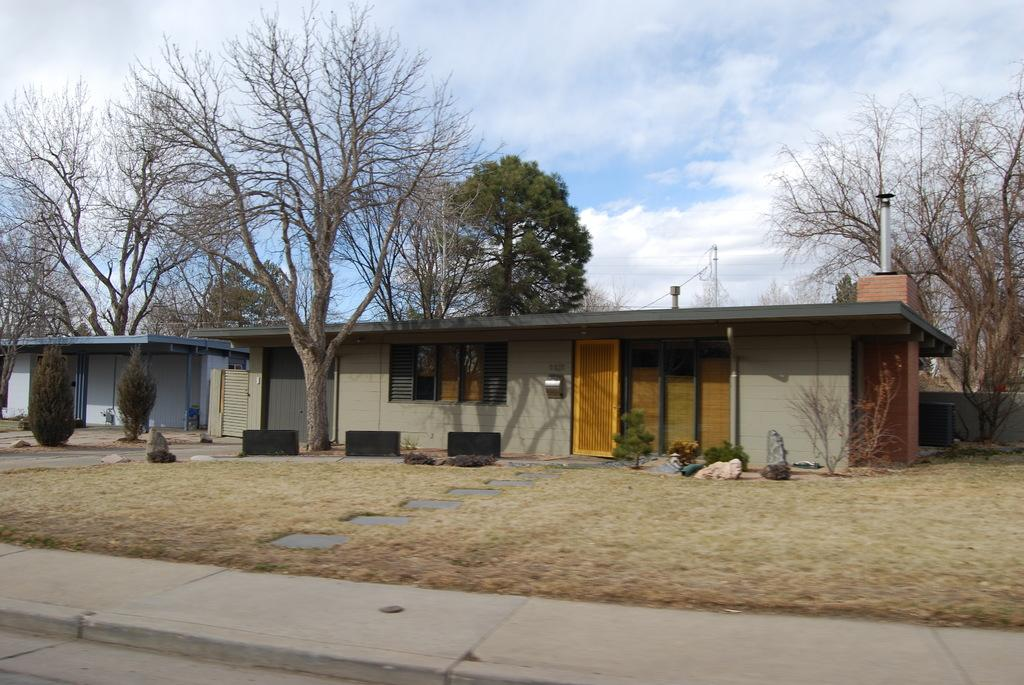What structures are located in the center of the image? There are sheds in the center of the image. What type of vegetation can be seen in the image? There are trees in the image. What can be found on the left side of the image? There are bushes on the left side of the image. What is visible in the background of the image? The sky is visible in the background of the image. How many mittens are hanging on the trees in the image? There are no mittens present in the image; it features sheds, trees, bushes, and the sky. What is the image trying to pull the viewer's attention towards? The image is not trying to pull the viewer's attention towards any specific object or subject, as it is a static representation of the scene. 